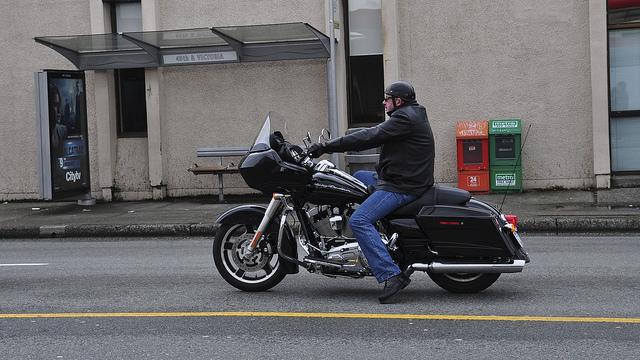What are the orange and green things against the wall?
Answer briefly. Newspaper stands. How old is the man?
Be succinct. 45. Do you like this motorcycle?
Concise answer only. Yes. Is the bike going fast?
Answer briefly. No. 